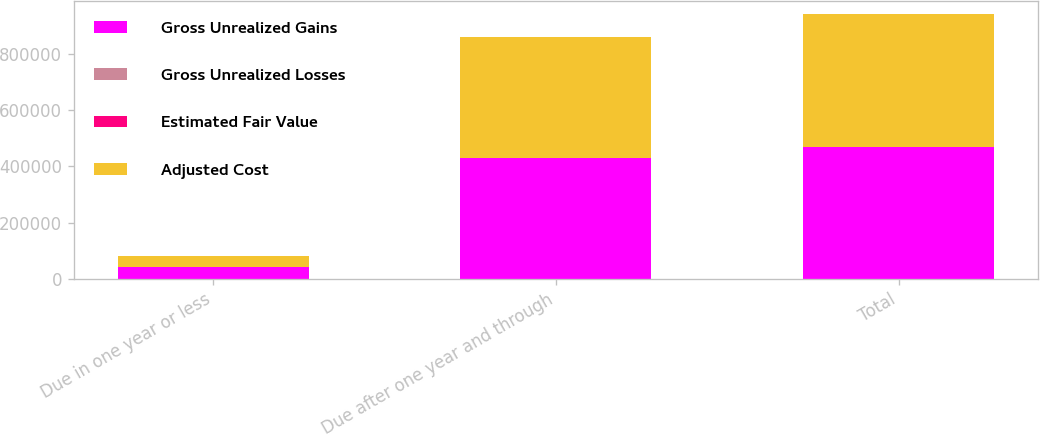<chart> <loc_0><loc_0><loc_500><loc_500><stacked_bar_chart><ecel><fcel>Due in one year or less<fcel>Due after one year and through<fcel>Total<nl><fcel>Gross Unrealized Gains<fcel>41078<fcel>428212<fcel>469290<nl><fcel>Gross Unrealized Losses<fcel>5<fcel>434<fcel>439<nl><fcel>Estimated Fair Value<fcel>5<fcel>94<fcel>99<nl><fcel>Adjusted Cost<fcel>41078<fcel>428552<fcel>469630<nl></chart> 